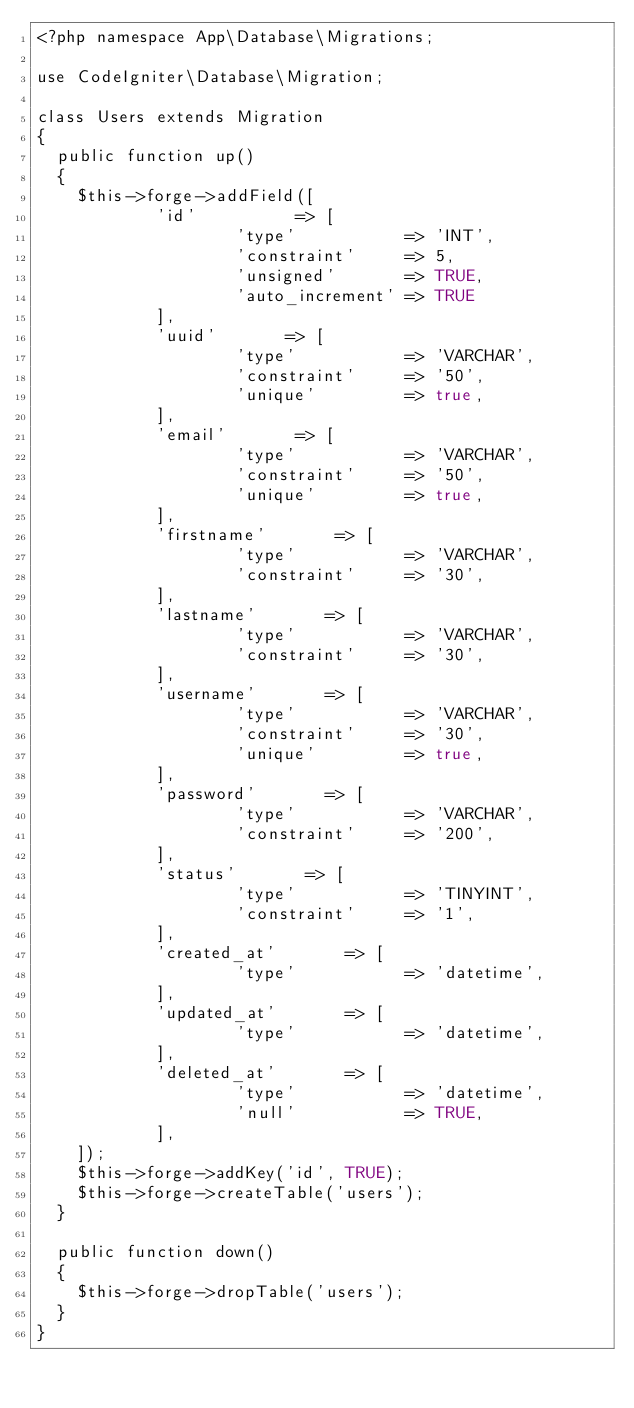Convert code to text. <code><loc_0><loc_0><loc_500><loc_500><_PHP_><?php namespace App\Database\Migrations;

use CodeIgniter\Database\Migration;

class Users extends Migration
{
	public function up()
	{
		$this->forge->addField([
            'id'          => [
                    'type'           => 'INT',
                    'constraint'     => 5,
                    'unsigned'       => TRUE,
                    'auto_increment' => TRUE
            ],
						'uuid'       => [
                    'type'           => 'VARCHAR',
                    'constraint'     => '50',
										'unique'         => true,
            ],
						'email'       => [
                    'type'           => 'VARCHAR',
                    'constraint'     => '50',
										'unique'         => true,
            ],
            'firstname'       => [
                    'type'           => 'VARCHAR',
                    'constraint'     => '30',
            ],
						'lastname'       => [
                    'type'           => 'VARCHAR',
                    'constraint'     => '30',
            ],
						'username'       => [
                    'type'           => 'VARCHAR',
                    'constraint'     => '30',
										'unique'         => true,
            ],
						'password'       => [
                    'type'           => 'VARCHAR',
                    'constraint'     => '200',
            ],
						'status'       => [
                    'type'           => 'TINYINT',
                    'constraint'     => '1',
            ],
						'created_at'       => [
                    'type'           => 'datetime',
            ],
						'updated_at'       => [
                    'type'           => 'datetime',
            ],
						'deleted_at'       => [
                    'type'           => 'datetime',
										'null'					 =>	TRUE,
            ],
    ]);
    $this->forge->addKey('id', TRUE);
    $this->forge->createTable('users');
	}

	public function down()
	{
		$this->forge->dropTable('users');
	}
}
</code> 